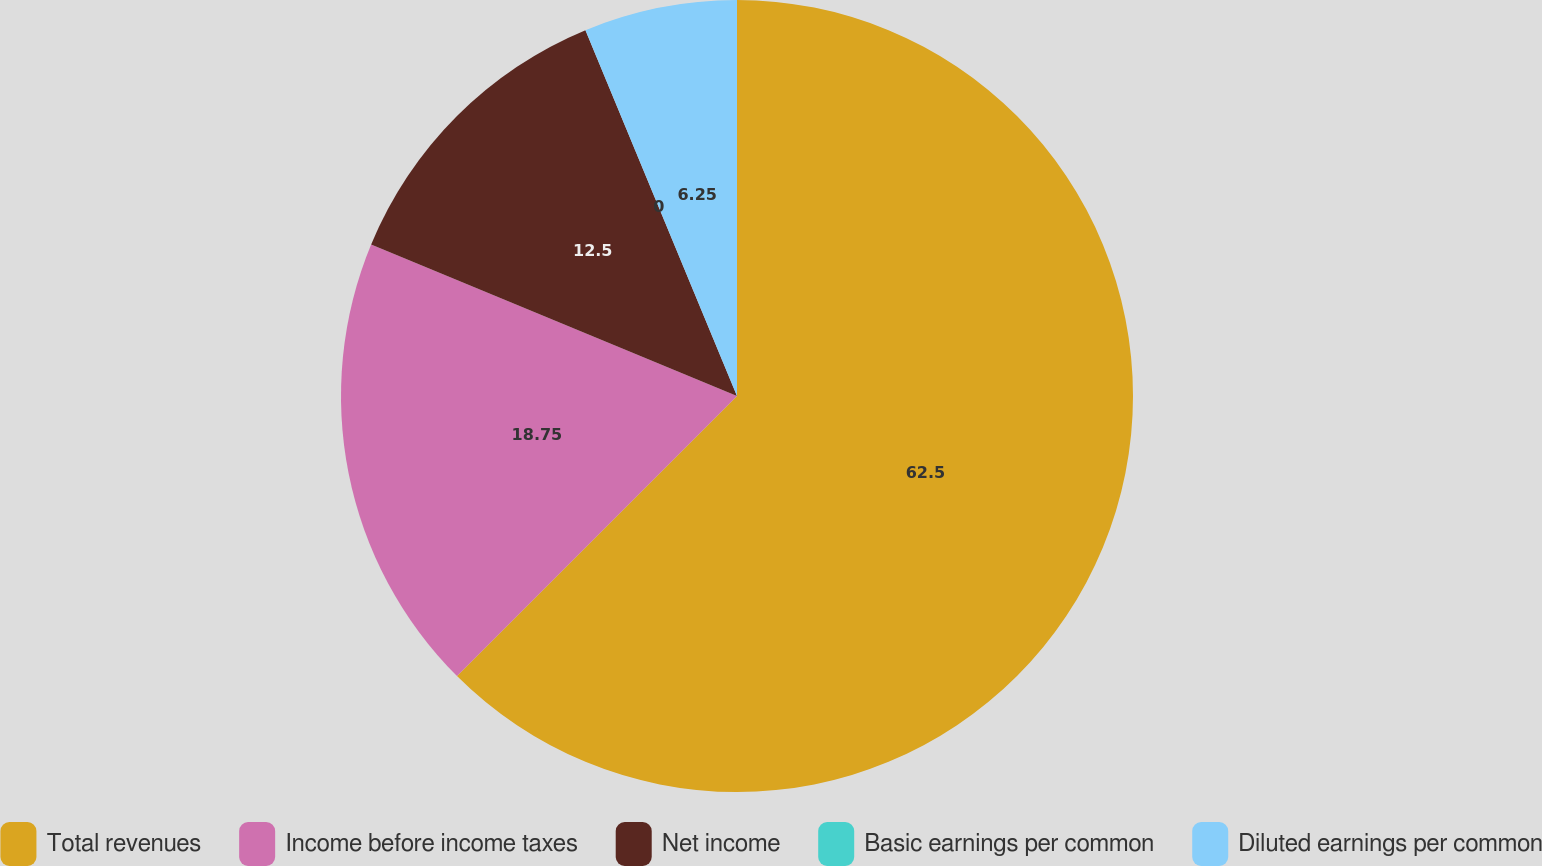<chart> <loc_0><loc_0><loc_500><loc_500><pie_chart><fcel>Total revenues<fcel>Income before income taxes<fcel>Net income<fcel>Basic earnings per common<fcel>Diluted earnings per common<nl><fcel>62.5%<fcel>18.75%<fcel>12.5%<fcel>0.0%<fcel>6.25%<nl></chart> 